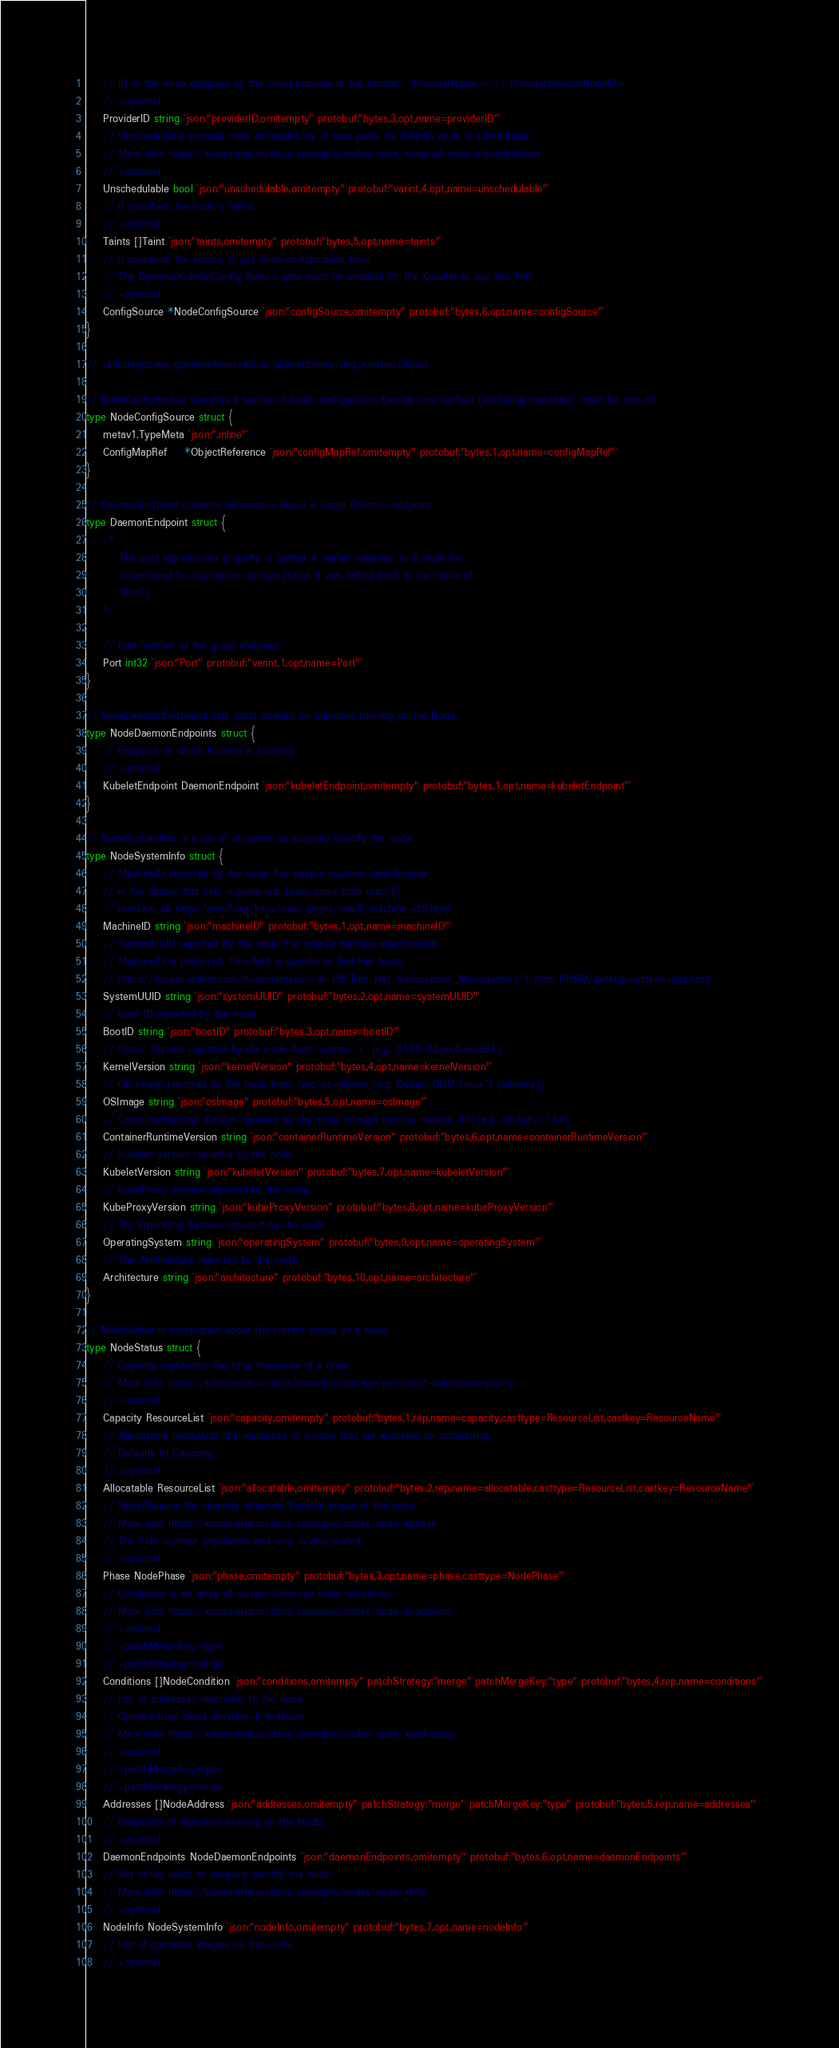Convert code to text. <code><loc_0><loc_0><loc_500><loc_500><_Go_>	// ID of the node assigned by the cloud provider in the format: <ProviderName>://<ProviderSpecificNodeID>
	// +optional
	ProviderID string `json:"providerID,omitempty" protobuf:"bytes,3,opt,name=providerID"`
	// Unschedulable controls node schedulability of new pods. By default, node is schedulable.
	// More info: https://kubernetes.io/docs/concepts/nodes/node/#manual-node-administration
	// +optional
	Unschedulable bool `json:"unschedulable,omitempty" protobuf:"varint,4,opt,name=unschedulable"`
	// If specified, the node's taints.
	// +optional
	Taints []Taint `json:"taints,omitempty" protobuf:"bytes,5,opt,name=taints"`
	// If specified, the source to get node configuration from
	// The DynamicKubeletConfig feature gate must be enabled for the Kubelet to use this field
	// +optional
	ConfigSource *NodeConfigSource `json:"configSource,omitempty" protobuf:"bytes,6,opt,name=configSource"`
}

// +k8s:deepcopy-gen:interfaces=k8s.io/apimachinery/pkg/runtime.Object

// NodeConfigSource specifies a source of node configuration. Exactly one subfield (excluding metadata) must be non-nil.
type NodeConfigSource struct {
	metav1.TypeMeta `json:",inline"`
	ConfigMapRef    *ObjectReference `json:"configMapRef,omitempty" protobuf:"bytes,1,opt,name=configMapRef"`
}

// DaemonEndpoint contains information about a single Daemon endpoint.
type DaemonEndpoint struct {
	/*
		The port tag was not properly in quotes in earlier releases, so it must be
		uppercased for backwards compat (since it was falling back to var name of
		'Port').
	*/

	// Port number of the given endpoint.
	Port int32 `json:"Port" protobuf:"varint,1,opt,name=Port"`
}

// NodeDaemonEndpoints lists ports opened by daemons running on the Node.
type NodeDaemonEndpoints struct {
	// Endpoint on which Kubelet is listening.
	// +optional
	KubeletEndpoint DaemonEndpoint `json:"kubeletEndpoint,omitempty" protobuf:"bytes,1,opt,name=kubeletEndpoint"`
}

// NodeSystemInfo is a set of ids/uuids to uniquely identify the node.
type NodeSystemInfo struct {
	// MachineID reported by the node. For unique machine identification
	// in the cluster this field is preferred. Learn more from man(5)
	// machine-id: http://man7.org/linux/man-pages/man5/machine-id.5.html
	MachineID string `json:"machineID" protobuf:"bytes,1,opt,name=machineID"`
	// SystemUUID reported by the node. For unique machine identification
	// MachineID is preferred. This field is specific to Red Hat hosts
	// https://access.redhat.com/documentation/en-US/Red_Hat_Subscription_Management/1/html/RHSM/getting-system-uuid.html
	SystemUUID string `json:"systemUUID" protobuf:"bytes,2,opt,name=systemUUID"`
	// Boot ID reported by the node.
	BootID string `json:"bootID" protobuf:"bytes,3,opt,name=bootID"`
	// Kernel Version reported by the node from 'uname -r' (e.g. 3.16.0-0.bpo.4-amd64).
	KernelVersion string `json:"kernelVersion" protobuf:"bytes,4,opt,name=kernelVersion"`
	// OS Image reported by the node from /etc/os-release (e.g. Debian GNU/Linux 7 (wheezy)).
	OSImage string `json:"osImage" protobuf:"bytes,5,opt,name=osImage"`
	// ContainerRuntime Version reported by the node through runtime remote API (e.g. docker://1.5.0).
	ContainerRuntimeVersion string `json:"containerRuntimeVersion" protobuf:"bytes,6,opt,name=containerRuntimeVersion"`
	// Kubelet Version reported by the node.
	KubeletVersion string `json:"kubeletVersion" protobuf:"bytes,7,opt,name=kubeletVersion"`
	// KubeProxy Version reported by the node.
	KubeProxyVersion string `json:"kubeProxyVersion" protobuf:"bytes,8,opt,name=kubeProxyVersion"`
	// The Operating System reported by the node
	OperatingSystem string `json:"operatingSystem" protobuf:"bytes,9,opt,name=operatingSystem"`
	// The Architecture reported by the node
	Architecture string `json:"architecture" protobuf:"bytes,10,opt,name=architecture"`
}

// NodeStatus is information about the current status of a node.
type NodeStatus struct {
	// Capacity represents the total resources of a node.
	// More info: https://kubernetes.io/docs/concepts/storage/persistent-volumes#capacity
	// +optional
	Capacity ResourceList `json:"capacity,omitempty" protobuf:"bytes,1,rep,name=capacity,casttype=ResourceList,castkey=ResourceName"`
	// Allocatable represents the resources of a node that are available for scheduling.
	// Defaults to Capacity.
	// +optional
	Allocatable ResourceList `json:"allocatable,omitempty" protobuf:"bytes,2,rep,name=allocatable,casttype=ResourceList,castkey=ResourceName"`
	// NodePhase is the recently observed lifecycle phase of the node.
	// More info: https://kubernetes.io/docs/concepts/nodes/node/#phase
	// The field is never populated, and now is deprecated.
	// +optional
	Phase NodePhase `json:"phase,omitempty" protobuf:"bytes,3,opt,name=phase,casttype=NodePhase"`
	// Conditions is an array of current observed node conditions.
	// More info: https://kubernetes.io/docs/concepts/nodes/node/#condition
	// +optional
	// +patchMergeKey=type
	// +patchStrategy=merge
	Conditions []NodeCondition `json:"conditions,omitempty" patchStrategy:"merge" patchMergeKey:"type" protobuf:"bytes,4,rep,name=conditions"`
	// List of addresses reachable to the node.
	// Queried from cloud provider, if available.
	// More info: https://kubernetes.io/docs/concepts/nodes/node/#addresses
	// +optional
	// +patchMergeKey=type
	// +patchStrategy=merge
	Addresses []NodeAddress `json:"addresses,omitempty" patchStrategy:"merge" patchMergeKey:"type" protobuf:"bytes,5,rep,name=addresses"`
	// Endpoints of daemons running on the Node.
	// +optional
	DaemonEndpoints NodeDaemonEndpoints `json:"daemonEndpoints,omitempty" protobuf:"bytes,6,opt,name=daemonEndpoints"`
	// Set of ids/uuids to uniquely identify the node.
	// More info: https://kubernetes.io/docs/concepts/nodes/node/#info
	// +optional
	NodeInfo NodeSystemInfo `json:"nodeInfo,omitempty" protobuf:"bytes,7,opt,name=nodeInfo"`
	// List of container images on this node
	// +optional</code> 